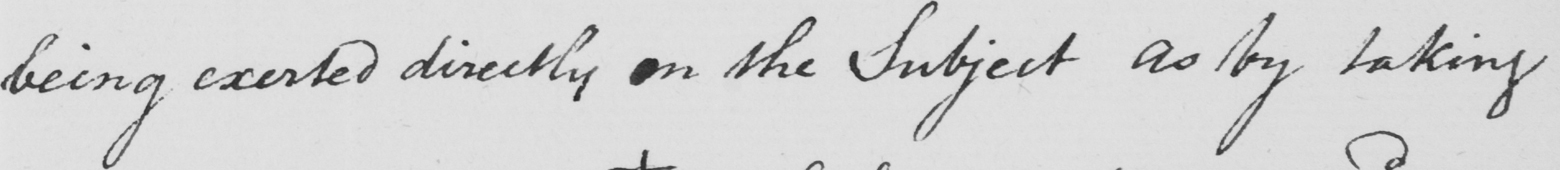Can you tell me what this handwritten text says? being exerted directly on the Subject as by taking 